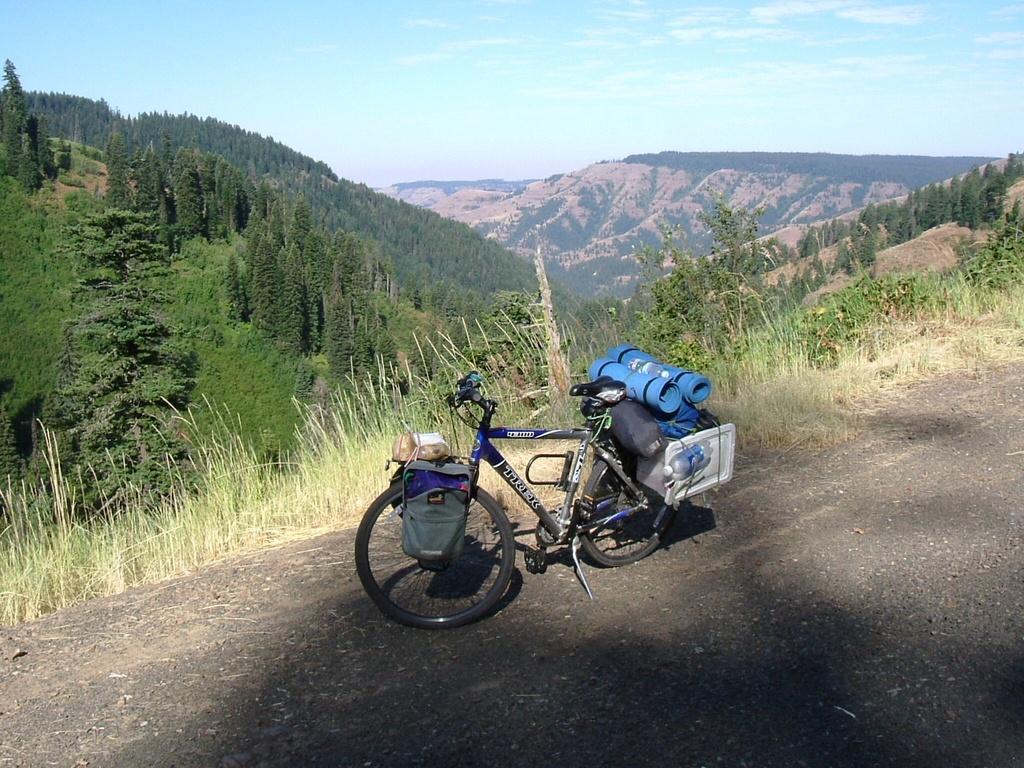In one or two sentences, can you explain what this image depicts? In this image in front there is a cycle on the road and on cycle there are few objects. Behind the cycle, there's grass on the surface. In the background there are trees, mountains and sky. 